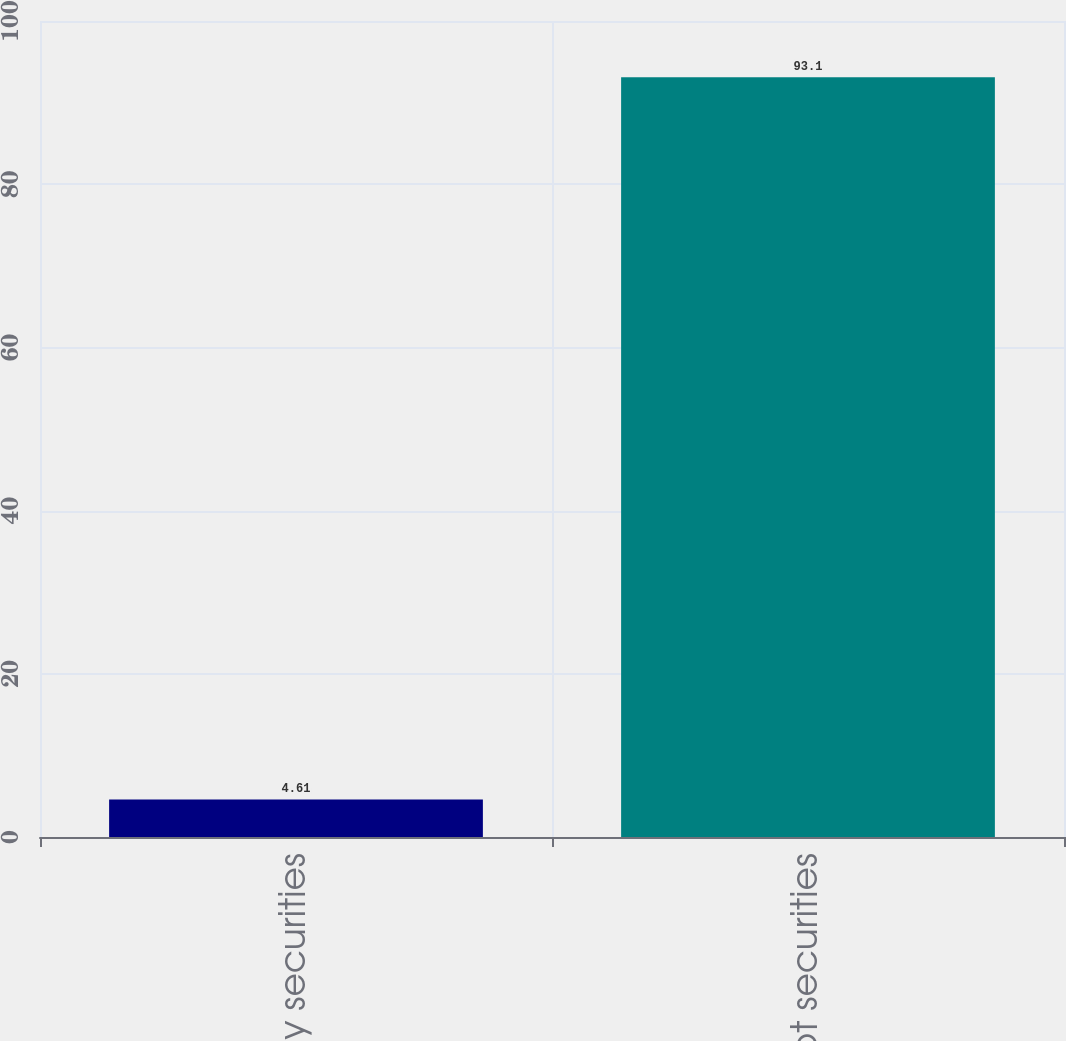<chart> <loc_0><loc_0><loc_500><loc_500><bar_chart><fcel>Equity securities<fcel>Debt securities<nl><fcel>4.61<fcel>93.1<nl></chart> 